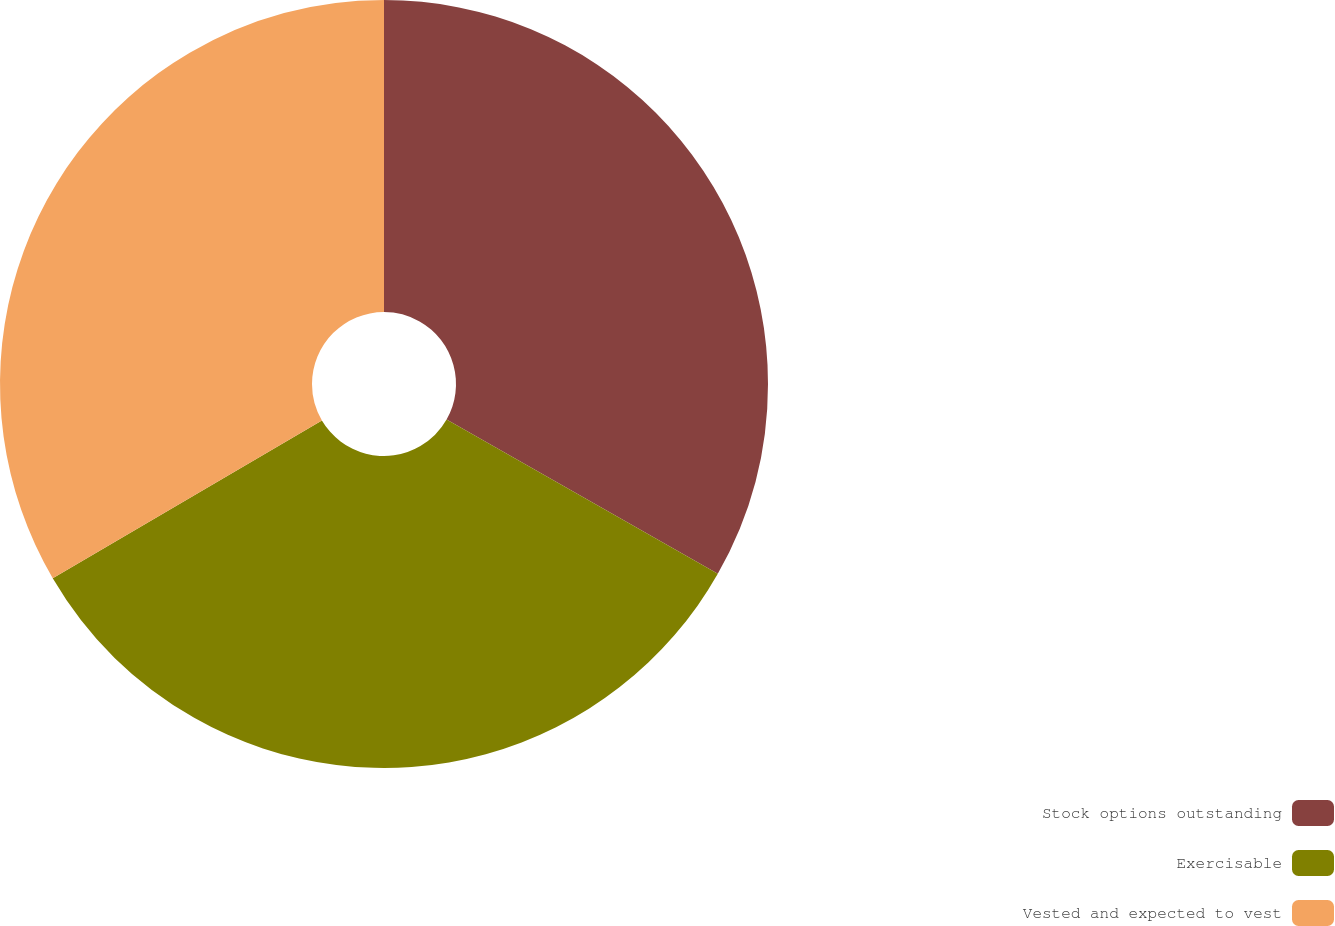<chart> <loc_0><loc_0><loc_500><loc_500><pie_chart><fcel>Stock options outstanding<fcel>Exercisable<fcel>Vested and expected to vest<nl><fcel>33.23%<fcel>33.33%<fcel>33.44%<nl></chart> 